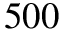Convert formula to latex. <formula><loc_0><loc_0><loc_500><loc_500>5 0 0</formula> 